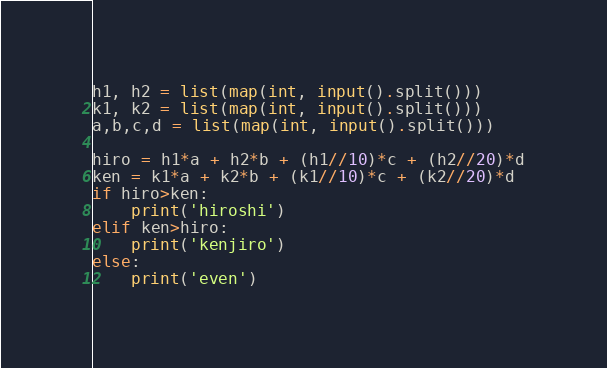<code> <loc_0><loc_0><loc_500><loc_500><_Python_>h1, h2 = list(map(int, input().split()))
k1, k2 = list(map(int, input().split()))
a,b,c,d = list(map(int, input().split()))

hiro = h1*a + h2*b + (h1//10)*c + (h2//20)*d
ken = k1*a + k2*b + (k1//10)*c + (k2//20)*d
if hiro>ken:
    print('hiroshi')
elif ken>hiro:
    print('kenjiro')
else:
    print('even')
</code> 